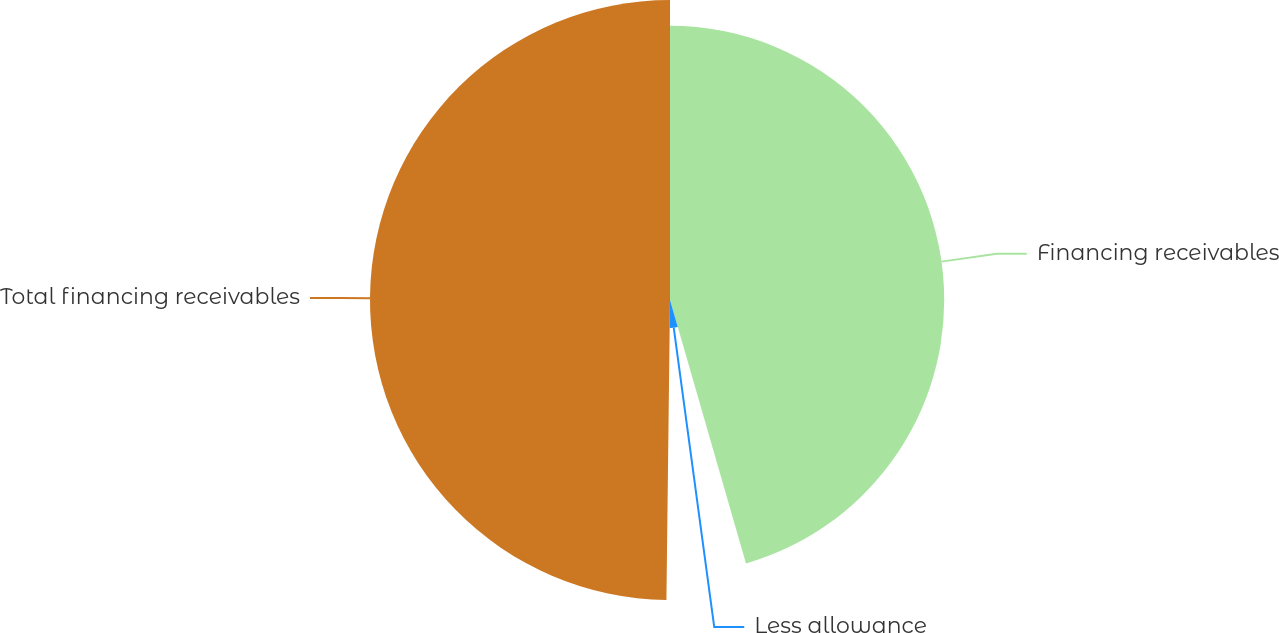Convert chart to OTSL. <chart><loc_0><loc_0><loc_500><loc_500><pie_chart><fcel>Financing receivables<fcel>Less allowance<fcel>Total financing receivables<nl><fcel>45.53%<fcel>4.66%<fcel>49.81%<nl></chart> 